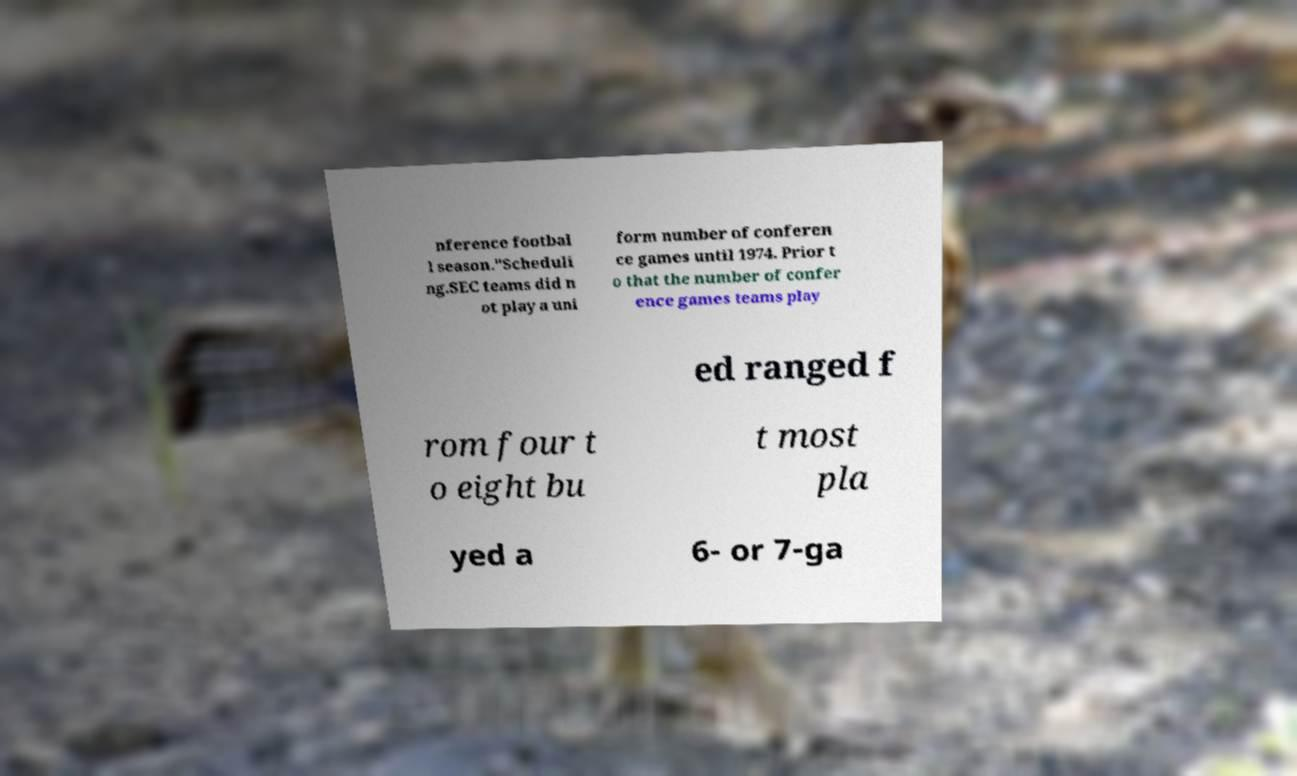Please identify and transcribe the text found in this image. nference footbal l season."Scheduli ng.SEC teams did n ot play a uni form number of conferen ce games until 1974. Prior t o that the number of confer ence games teams play ed ranged f rom four t o eight bu t most pla yed a 6- or 7-ga 